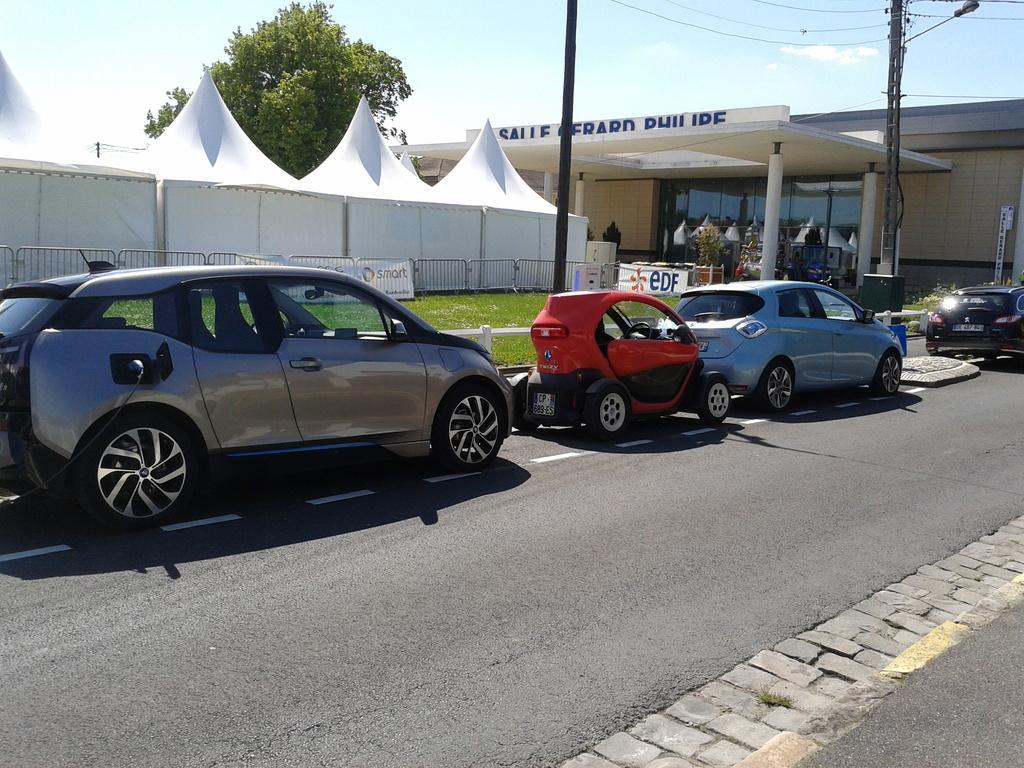Could you give a brief overview of what you see in this image? In this image there are cars parked on the road, beside the road there is a wooden fence, behind the fence there is grass on the surface. In the background of the image there is a metal rod fence, on the fence there are banners, behind the banners there are tents and trees. In front of the tents there are buildings and electric poles with cables and lamps on it. 